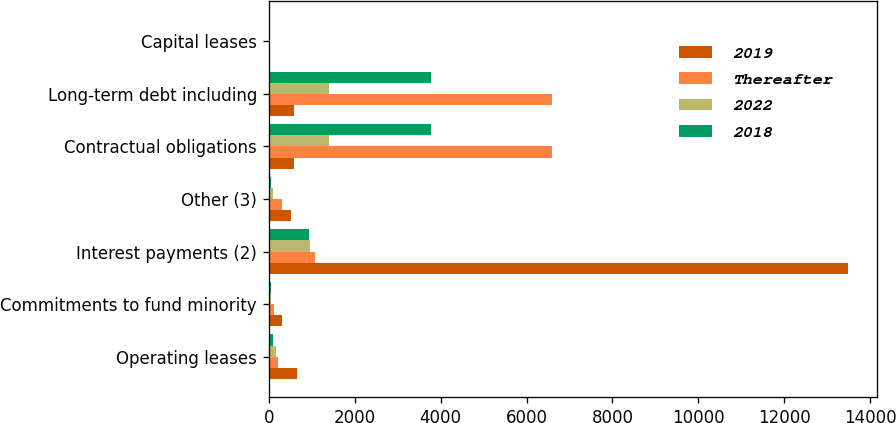Convert chart to OTSL. <chart><loc_0><loc_0><loc_500><loc_500><stacked_bar_chart><ecel><fcel>Operating leases<fcel>Commitments to fund minority<fcel>Interest payments (2)<fcel>Other (3)<fcel>Contractual obligations<fcel>Long-term debt including<fcel>Capital leases<nl><fcel>2019<fcel>646<fcel>308<fcel>13488<fcel>513<fcel>579.5<fcel>579.5<fcel>23<nl><fcel>Thereafter<fcel>215<fcel>125<fcel>1077<fcel>304<fcel>6593<fcel>6588<fcel>5<nl><fcel>2022<fcel>158<fcel>50<fcel>967<fcel>89<fcel>1406<fcel>1402<fcel>4<nl><fcel>2018<fcel>110<fcel>47<fcel>929<fcel>50<fcel>3781<fcel>3779<fcel>2<nl></chart> 